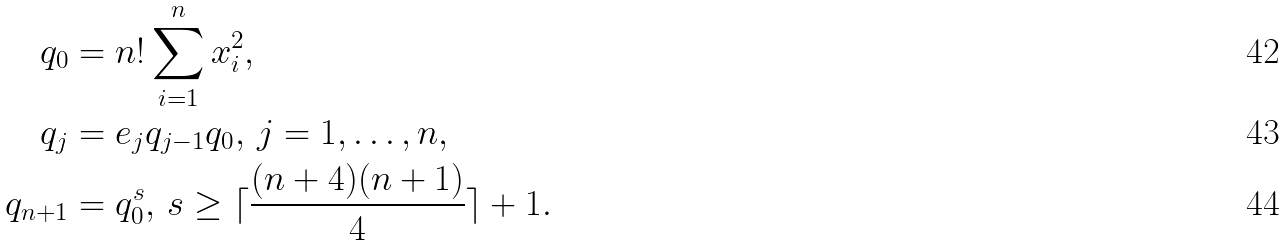<formula> <loc_0><loc_0><loc_500><loc_500>q _ { 0 } & = n ! \sum _ { i = 1 } ^ { n } x _ { i } ^ { 2 } , \\ q _ { j } & = e _ { j } q _ { j - 1 } q _ { 0 } , \, j = 1 , \dots , n , \\ q _ { n + 1 } & = q _ { 0 } ^ { s } , \, s \geq \lceil \frac { ( n + 4 ) ( n + 1 ) } { 4 } \rceil + 1 .</formula> 